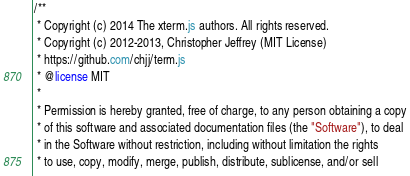<code> <loc_0><loc_0><loc_500><loc_500><_CSS_>/**
 * Copyright (c) 2014 The xterm.js authors. All rights reserved.
 * Copyright (c) 2012-2013, Christopher Jeffrey (MIT License)
 * https://github.com/chjj/term.js
 * @license MIT
 *
 * Permission is hereby granted, free of charge, to any person obtaining a copy
 * of this software and associated documentation files (the "Software"), to deal
 * in the Software without restriction, including without limitation the rights
 * to use, copy, modify, merge, publish, distribute, sublicense, and/or sell</code> 